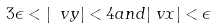Convert formula to latex. <formula><loc_0><loc_0><loc_500><loc_500>3 \epsilon < | \ v y | < 4 & a n d | \ v x | < \epsilon</formula> 